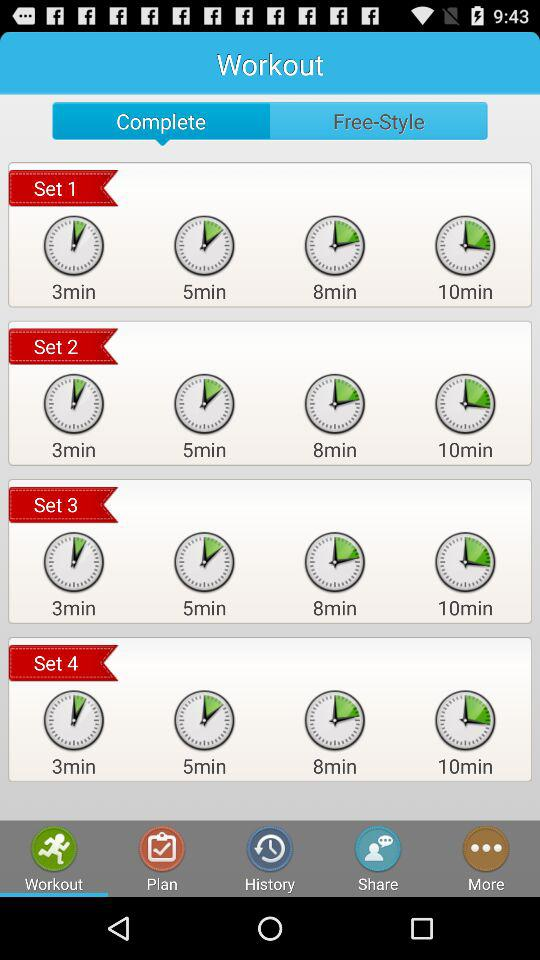How many sets are there in this workout?
Answer the question using a single word or phrase. 4 